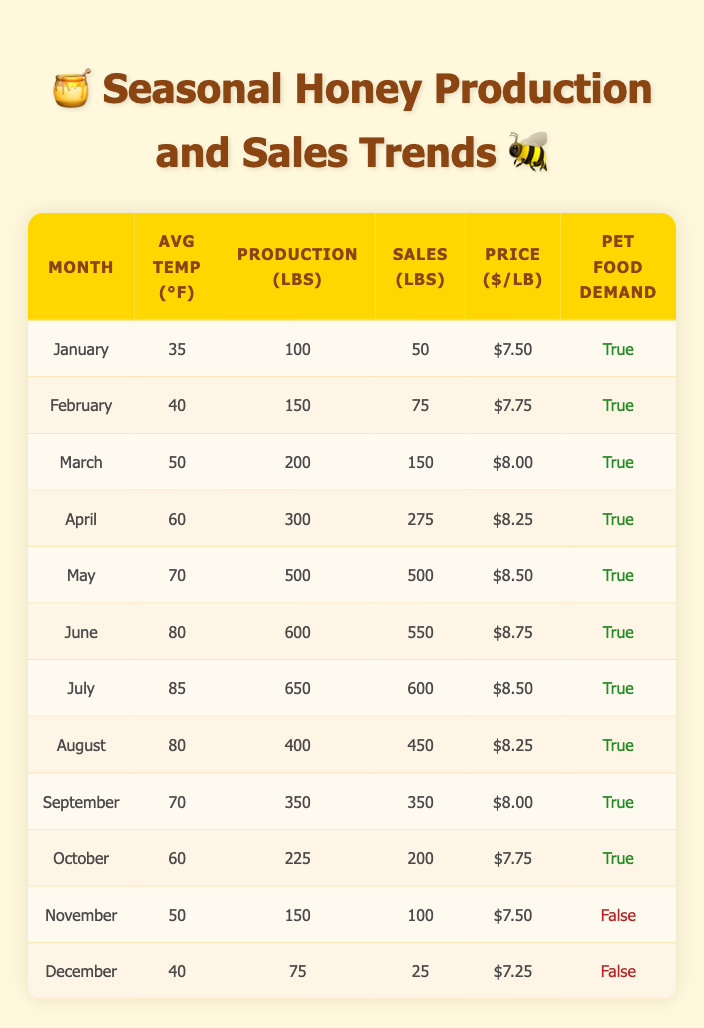What was the average honey production in the months when demand in pet foods was true? To find the average production during the months when demand in pet foods was true, we first identify those months: January, February, March, April, May, June, July, August, September, and October. Next, we sum the honey production from these months: (100 + 150 + 200 + 300 + 500 + 600 + 650 + 400 + 350 + 225) = 3075 lbs. Since there are 10 months, the average production is 3075 / 10 = 307.5 lbs.
Answer: 307.5 lbs In which month did the highest sales volume occur? By examining the sales volume column, we can see that May has the highest sales volume recorded at 500 lbs.
Answer: May Is the demand for honey in pet foods consistent throughout the year? By checking the demand status across the months, we notice that it is true for January to October, but false for November and December. Therefore, demand is not consistent throughout the year as it drops during the last two months.
Answer: No What is the total honey production from June to August? To find the total production from June to August, we sum the honey production of those months: June (600 lbs) + July (650 lbs) + August (400 lbs) = 600 + 650 + 400 = 1650 lbs.
Answer: 1650 lbs What was the average selling price per pound in the months with the highest production? The months with the highest production are May (500 lbs), June (600 lbs), and July (650 lbs). The prices for these months are $8.50, $8.75, and $8.50 respectively. The average price is calculated by summing them: (8.50 + 8.75 + 8.50) = 25.75, then dividing by 3 gives 25.75 / 3 = 8.5833, which rounds to $8.58 per lb.
Answer: $8.58 What was the relationship between average temperature and honey production? By analysing the data, we observe that as the average temperature increases from January to August, honey production also increases from 100 lbs in January to 650 lbs in July. However, there is a slight drop in production in August at 400 lbs while the temperature remains the same (80°F). This indicates a general positive correlation but not a direct linear relationship.
Answer: Generally positive correlation with fluctuations 